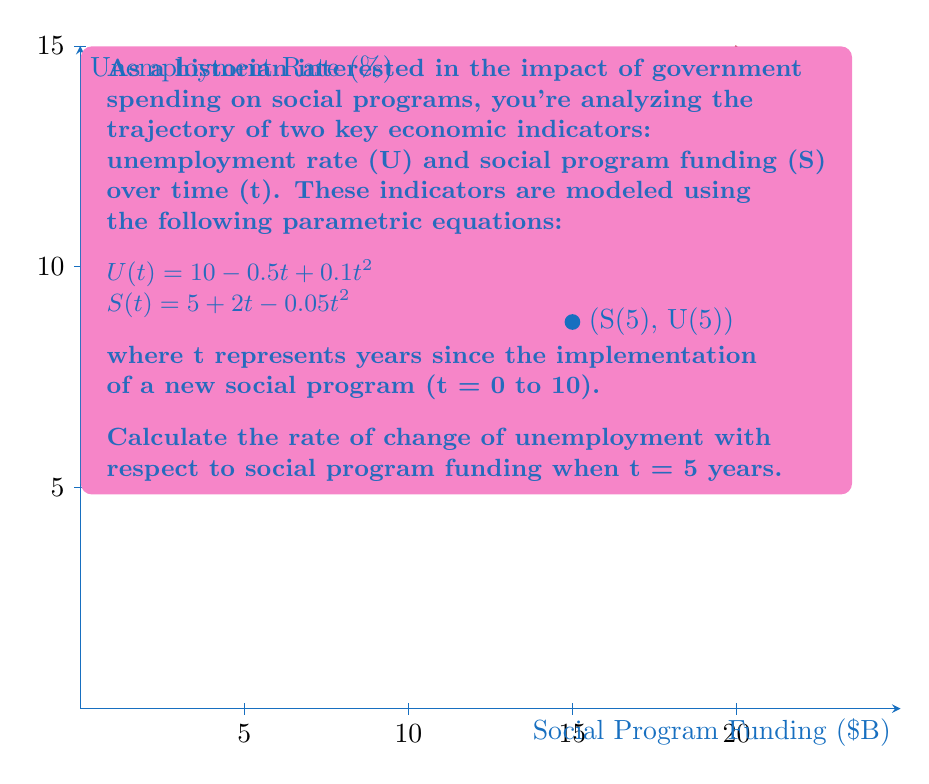Can you answer this question? To find the rate of change of unemployment with respect to social program funding, we need to calculate $\frac{dU}{dS}$ using the chain rule:

$$\frac{dU}{dS} = \frac{dU/dt}{dS/dt}$$

Step 1: Calculate $\frac{dU}{dt}$ and $\frac{dS}{dt}$
$$\frac{dU}{dt} = -0.5 + 0.2t$$
$$\frac{dS}{dt} = 2 - 0.1t$$

Step 2: Evaluate $\frac{dU}{dt}$ and $\frac{dS}{dt}$ at t = 5
$$\frac{dU}{dt}\bigg|_{t=5} = -0.5 + 0.2(5) = 0.5$$
$$\frac{dS}{dt}\bigg|_{t=5} = 2 - 0.1(5) = 1.5$$

Step 3: Calculate $\frac{dU}{dS}$ at t = 5
$$\frac{dU}{dS}\bigg|_{t=5} = \frac{0.5}{1.5} = \frac{1}{3}$$

This means that when t = 5 years, for every unit increase in social program funding, the unemployment rate increases by 1/3 of a unit.
Answer: $\frac{1}{3}$ 